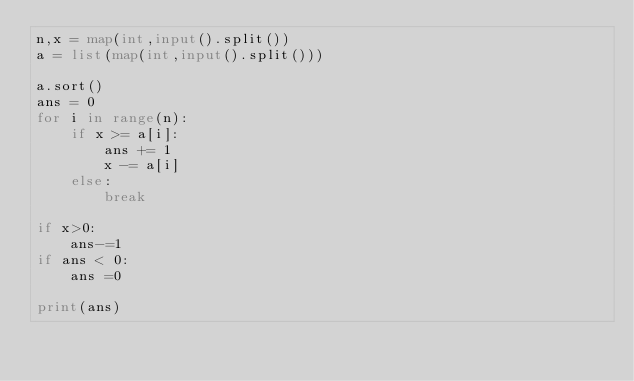Convert code to text. <code><loc_0><loc_0><loc_500><loc_500><_Python_>n,x = map(int,input().split())
a = list(map(int,input().split()))

a.sort()
ans = 0
for i in range(n):
    if x >= a[i]:
        ans += 1
        x -= a[i]
    else:
        break

if x>0:
    ans-=1
if ans < 0:
    ans =0

print(ans)</code> 